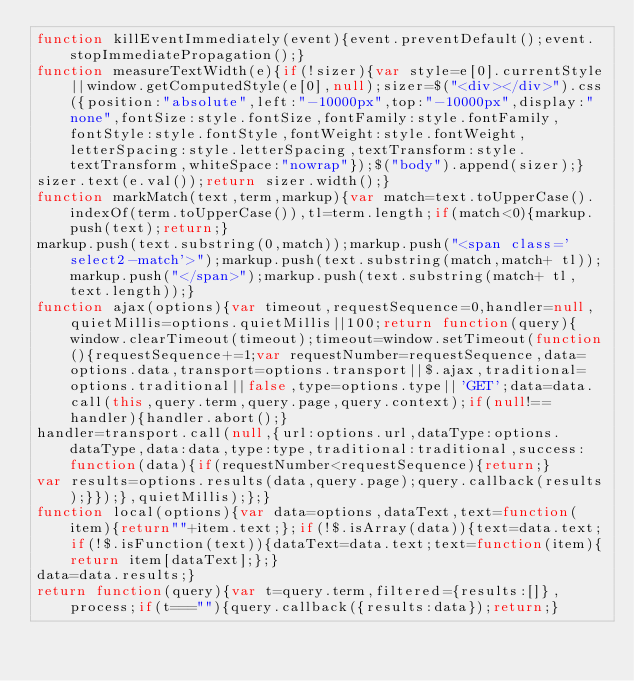Convert code to text. <code><loc_0><loc_0><loc_500><loc_500><_JavaScript_>function killEventImmediately(event){event.preventDefault();event.stopImmediatePropagation();}
function measureTextWidth(e){if(!sizer){var style=e[0].currentStyle||window.getComputedStyle(e[0],null);sizer=$("<div></div>").css({position:"absolute",left:"-10000px",top:"-10000px",display:"none",fontSize:style.fontSize,fontFamily:style.fontFamily,fontStyle:style.fontStyle,fontWeight:style.fontWeight,letterSpacing:style.letterSpacing,textTransform:style.textTransform,whiteSpace:"nowrap"});$("body").append(sizer);}
sizer.text(e.val());return sizer.width();}
function markMatch(text,term,markup){var match=text.toUpperCase().indexOf(term.toUpperCase()),tl=term.length;if(match<0){markup.push(text);return;}
markup.push(text.substring(0,match));markup.push("<span class='select2-match'>");markup.push(text.substring(match,match+ tl));markup.push("</span>");markup.push(text.substring(match+ tl,text.length));}
function ajax(options){var timeout,requestSequence=0,handler=null,quietMillis=options.quietMillis||100;return function(query){window.clearTimeout(timeout);timeout=window.setTimeout(function(){requestSequence+=1;var requestNumber=requestSequence,data=options.data,transport=options.transport||$.ajax,traditional=options.traditional||false,type=options.type||'GET';data=data.call(this,query.term,query.page,query.context);if(null!==handler){handler.abort();}
handler=transport.call(null,{url:options.url,dataType:options.dataType,data:data,type:type,traditional:traditional,success:function(data){if(requestNumber<requestSequence){return;}
var results=options.results(data,query.page);query.callback(results);}});},quietMillis);};}
function local(options){var data=options,dataText,text=function(item){return""+item.text;};if(!$.isArray(data)){text=data.text;if(!$.isFunction(text)){dataText=data.text;text=function(item){return item[dataText];};}
data=data.results;}
return function(query){var t=query.term,filtered={results:[]},process;if(t===""){query.callback({results:data});return;}</code> 